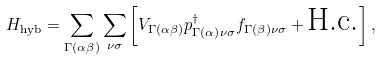Convert formula to latex. <formula><loc_0><loc_0><loc_500><loc_500>H _ { \text {hyb} } = \sum _ { \Gamma ( \alpha \beta ) } \sum _ { \nu \sigma } \left [ V _ { \Gamma { ( \alpha \beta ) } } p _ { \Gamma { ( \alpha ) } \nu \sigma } ^ { \dag } f _ { \Gamma { ( \beta ) } \nu \sigma } + \text {H.c.} \right ] ,</formula> 